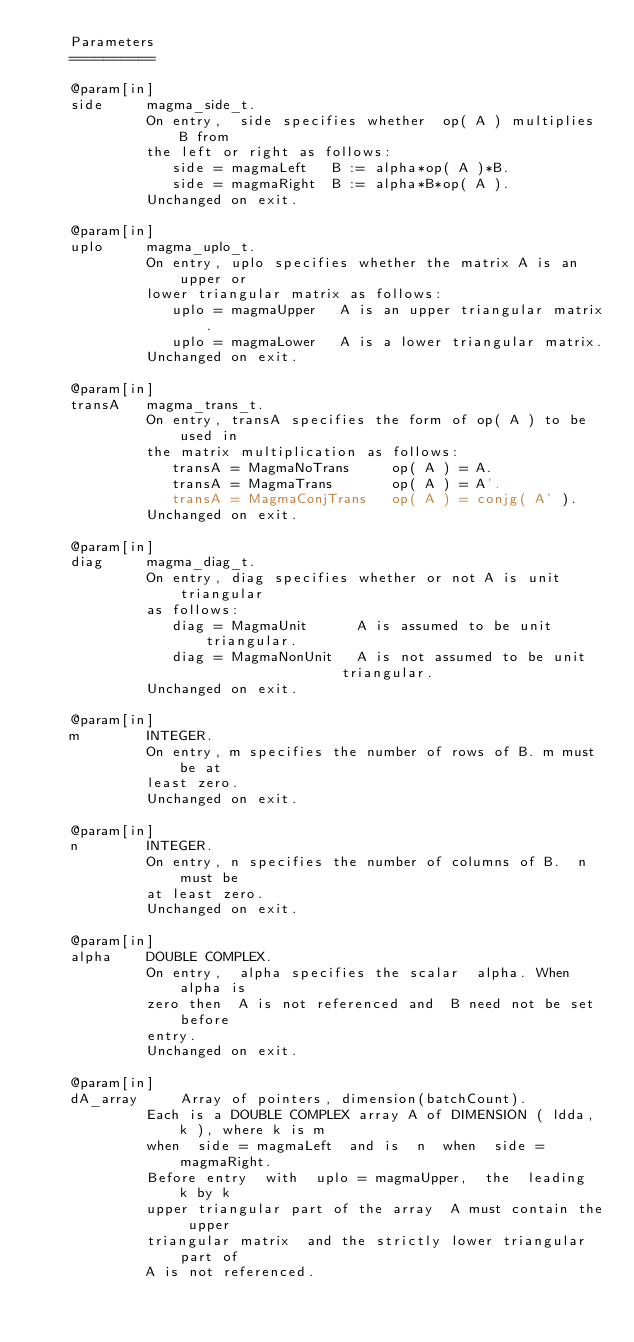Convert code to text. <code><loc_0><loc_0><loc_500><loc_500><_Cuda_>    Parameters   
    ==========   

    @param[in]
    side     magma_side_t.
             On entry,  side specifies whether  op( A ) multiplies B from 
             the left or right as follows:   
                side = magmaLeft   B := alpha*op( A )*B.   
                side = magmaRight  B := alpha*B*op( A ).   
             Unchanged on exit.   

    @param[in]
    uplo     magma_uplo_t.
             On entry, uplo specifies whether the matrix A is an upper or 
             lower triangular matrix as follows:   
                uplo = magmaUpper   A is an upper triangular matrix.   
                uplo = magmaLower   A is a lower triangular matrix.   
             Unchanged on exit.   

    @param[in]
    transA   magma_trans_t.
             On entry, transA specifies the form of op( A ) to be used in 
             the matrix multiplication as follows:   
                transA = MagmaNoTrans     op( A ) = A.   
                transA = MagmaTrans       op( A ) = A'.   
                transA = MagmaConjTrans   op( A ) = conjg( A' ).   
             Unchanged on exit.   

    @param[in]
    diag     magma_diag_t.
             On entry, diag specifies whether or not A is unit triangular 
             as follows:   
                diag = MagmaUnit      A is assumed to be unit triangular.   
                diag = MagmaNonUnit   A is not assumed to be unit   
                                    triangular.   
             Unchanged on exit.   

    @param[in]
    m        INTEGER.
             On entry, m specifies the number of rows of B. m must be at 
             least zero.   
             Unchanged on exit.   

    @param[in]
    n        INTEGER.   
             On entry, n specifies the number of columns of B.  n must be 
             at least zero.   
             Unchanged on exit.   

    @param[in]
    alpha    DOUBLE COMPLEX.
             On entry,  alpha specifies the scalar  alpha. When  alpha is 
             zero then  A is not referenced and  B need not be set before 
             entry.   
             Unchanged on exit.   

    @param[in]
    dA_array     Array of pointers, dimension(batchCount).
             Each is a DOUBLE COMPLEX array A of DIMENSION ( ldda, k ), where k is m 
             when  side = magmaLeft  and is  n  when  side = magmaRight. 
             Before entry  with  uplo = magmaUpper,  the  leading  k by k 
             upper triangular part of the array  A must contain the upper 
             triangular matrix  and the strictly lower triangular part of 
             A is not referenced.   </code> 